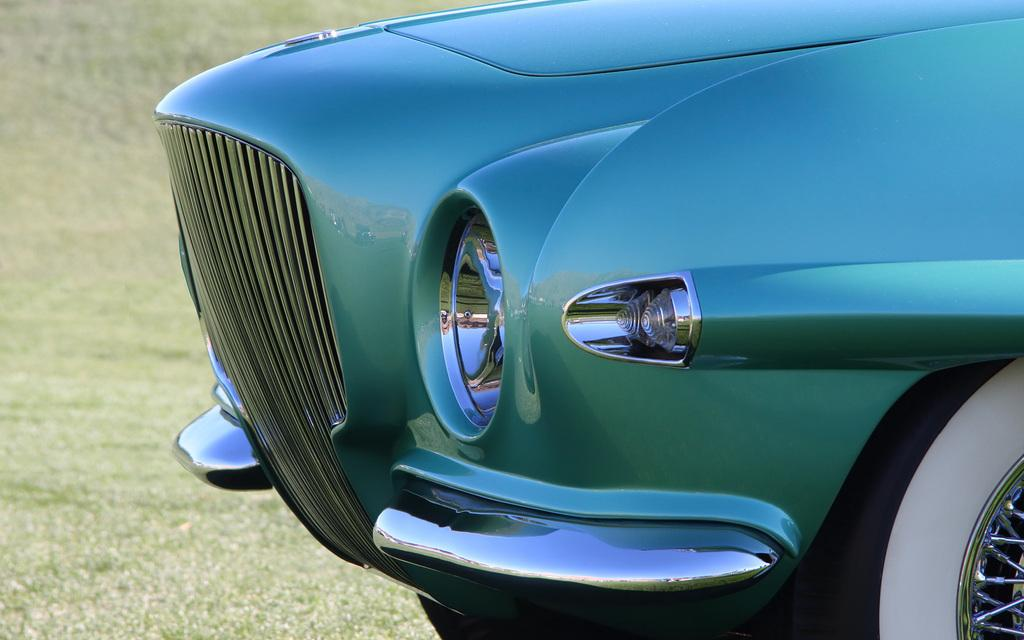What is the main subject of the image? There is a vehicle in the image. How is the vehicle positioned in relation to other elements in the image? The vehicle is in front of other elements in the image. What type of natural environment can be seen in the background of the image? There is grass visible in the background of the image. What type of map can be seen on the seat of the vehicle in the image? There is no map visible on the seat of the vehicle in the image. Can you tell me how many tubs are present in the image? There are no tubs present in the image. 